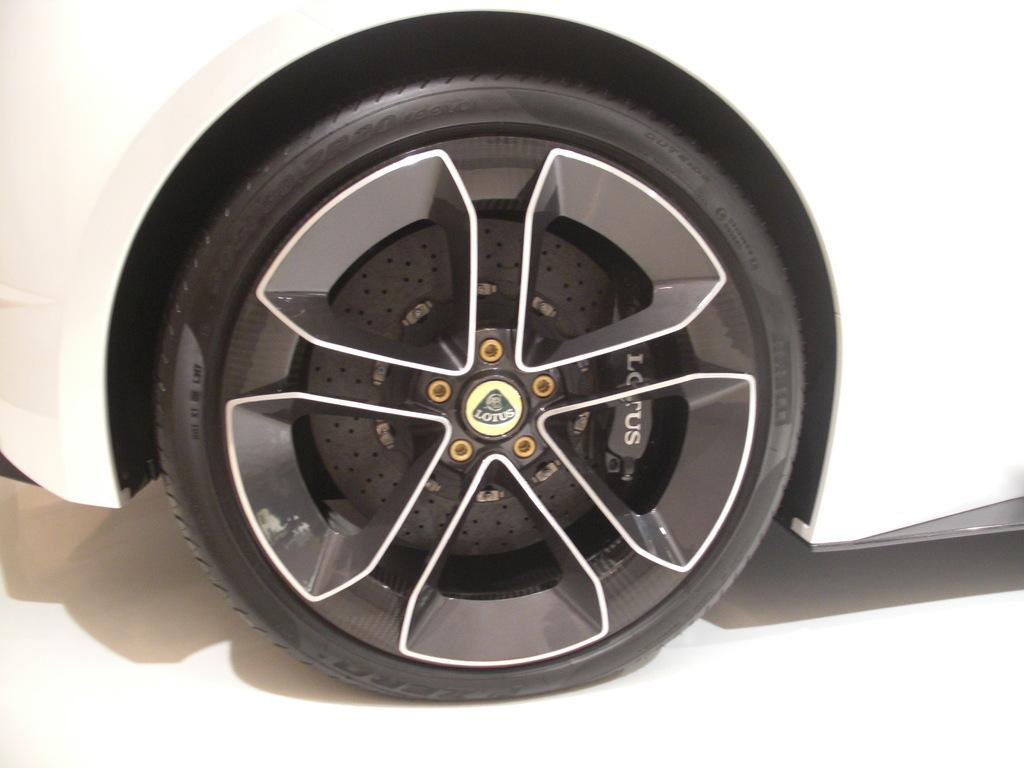What is the main subject of the image? There is a vehicle in the image. What color is the vehicle? The vehicle is white in color. What part of the vehicle can be seen in the image? There is a tire of the vehicle in the image. What colors are visible on the tire? The tire is black and grey in color. What is the color of the surface the vehicle is on? The vehicle is on a white-colored surface. What type of punishment is being administered to the baby on the stage in the image? There is no baby or stage present in the image; it only features a vehicle and a white-colored surface. 